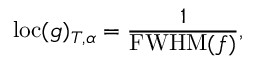Convert formula to latex. <formula><loc_0><loc_0><loc_500><loc_500>l o c ( g ) _ { T , \alpha } = \frac { 1 } { F W H M ( f ) } ,</formula> 